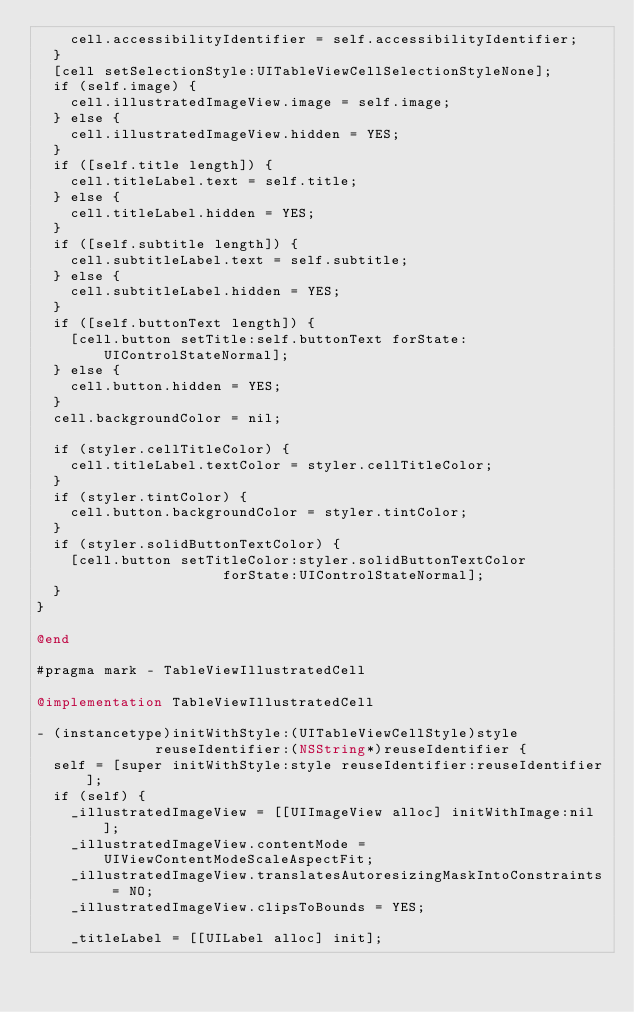<code> <loc_0><loc_0><loc_500><loc_500><_ObjectiveC_>    cell.accessibilityIdentifier = self.accessibilityIdentifier;
  }
  [cell setSelectionStyle:UITableViewCellSelectionStyleNone];
  if (self.image) {
    cell.illustratedImageView.image = self.image;
  } else {
    cell.illustratedImageView.hidden = YES;
  }
  if ([self.title length]) {
    cell.titleLabel.text = self.title;
  } else {
    cell.titleLabel.hidden = YES;
  }
  if ([self.subtitle length]) {
    cell.subtitleLabel.text = self.subtitle;
  } else {
    cell.subtitleLabel.hidden = YES;
  }
  if ([self.buttonText length]) {
    [cell.button setTitle:self.buttonText forState:UIControlStateNormal];
  } else {
    cell.button.hidden = YES;
  }
  cell.backgroundColor = nil;

  if (styler.cellTitleColor) {
    cell.titleLabel.textColor = styler.cellTitleColor;
  }
  if (styler.tintColor) {
    cell.button.backgroundColor = styler.tintColor;
  }
  if (styler.solidButtonTextColor) {
    [cell.button setTitleColor:styler.solidButtonTextColor
                      forState:UIControlStateNormal];
  }
}

@end

#pragma mark - TableViewIllustratedCell

@implementation TableViewIllustratedCell

- (instancetype)initWithStyle:(UITableViewCellStyle)style
              reuseIdentifier:(NSString*)reuseIdentifier {
  self = [super initWithStyle:style reuseIdentifier:reuseIdentifier];
  if (self) {
    _illustratedImageView = [[UIImageView alloc] initWithImage:nil];
    _illustratedImageView.contentMode = UIViewContentModeScaleAspectFit;
    _illustratedImageView.translatesAutoresizingMaskIntoConstraints = NO;
    _illustratedImageView.clipsToBounds = YES;

    _titleLabel = [[UILabel alloc] init];</code> 